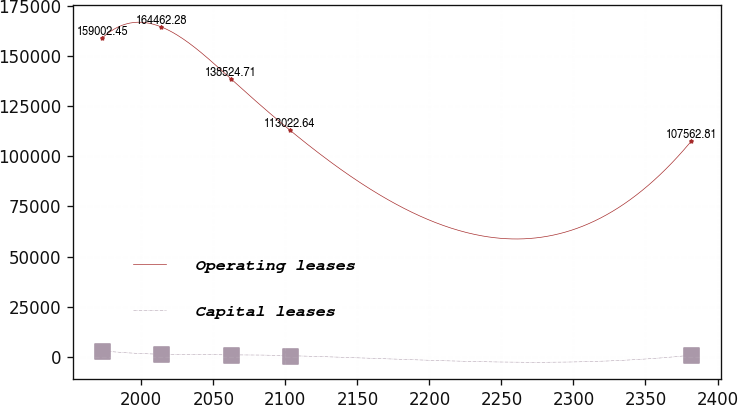Convert chart to OTSL. <chart><loc_0><loc_0><loc_500><loc_500><line_chart><ecel><fcel>Operating leases<fcel>Capital leases<nl><fcel>1972.95<fcel>159002<fcel>3086.97<nl><fcel>2013.84<fcel>164462<fcel>1369.91<nl><fcel>2062.26<fcel>138525<fcel>1124.62<nl><fcel>2103.15<fcel>113023<fcel>634.04<nl><fcel>2381.82<fcel>107563<fcel>879.33<nl></chart> 